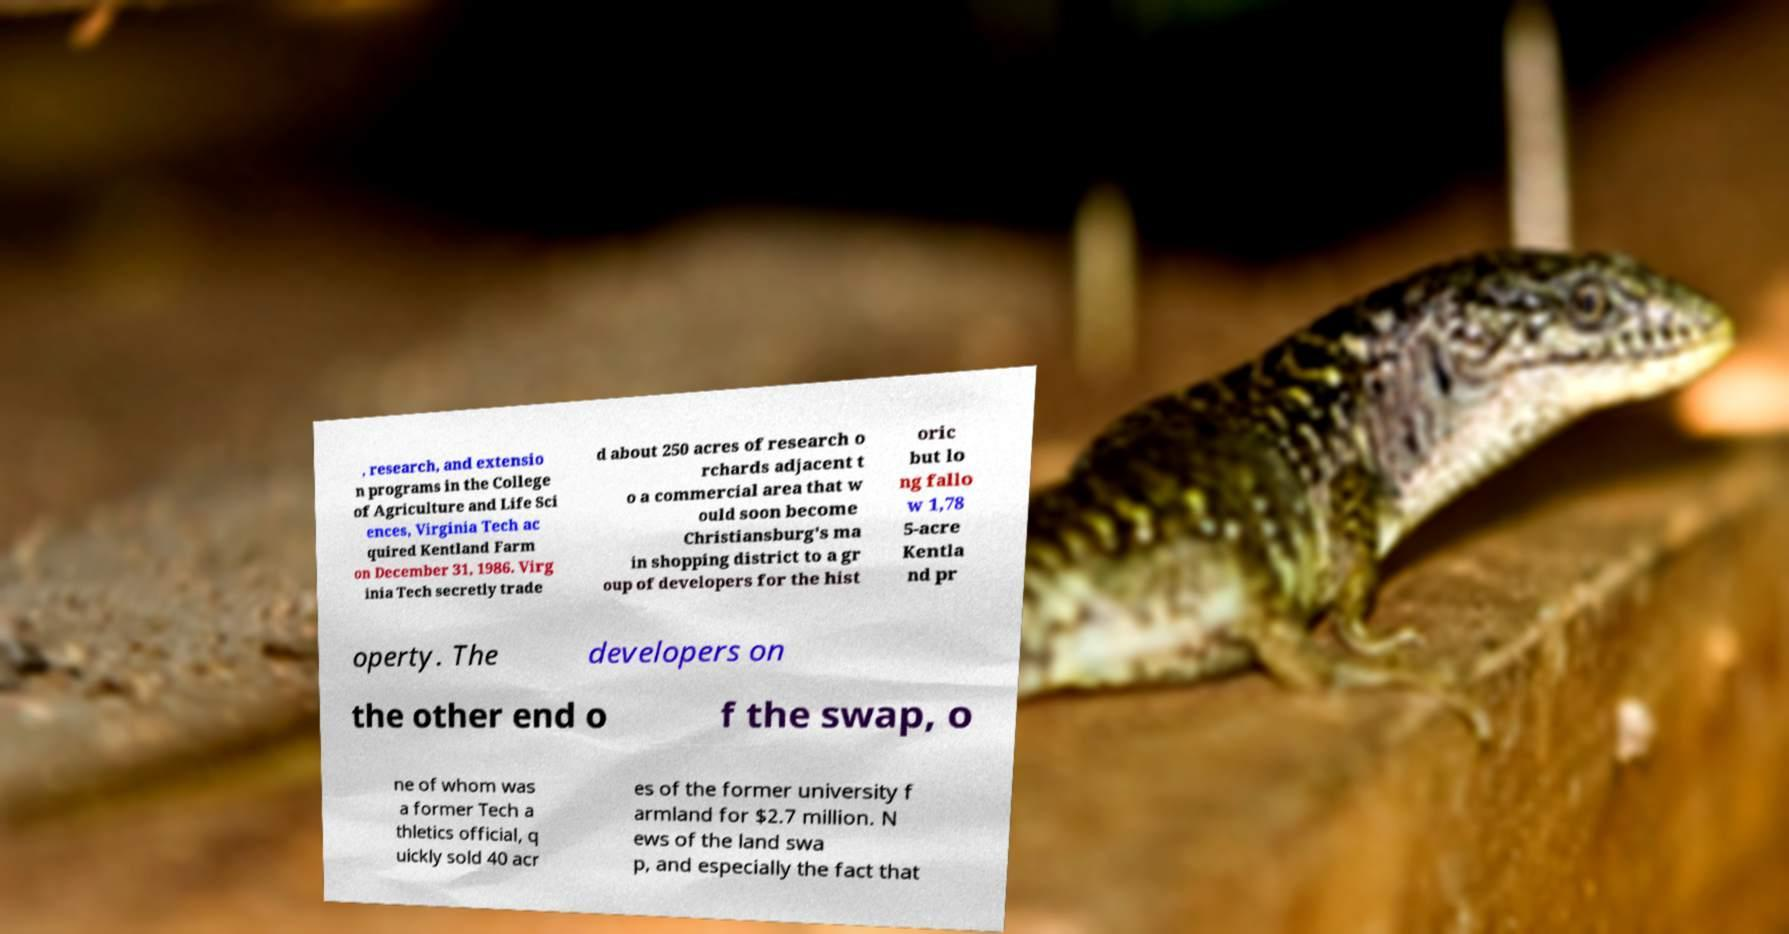Could you assist in decoding the text presented in this image and type it out clearly? , research, and extensio n programs in the College of Agriculture and Life Sci ences, Virginia Tech ac quired Kentland Farm on December 31, 1986. Virg inia Tech secretly trade d about 250 acres of research o rchards adjacent t o a commercial area that w ould soon become Christiansburg's ma in shopping district to a gr oup of developers for the hist oric but lo ng fallo w 1,78 5-acre Kentla nd pr operty. The developers on the other end o f the swap, o ne of whom was a former Tech a thletics official, q uickly sold 40 acr es of the former university f armland for $2.7 million. N ews of the land swa p, and especially the fact that 